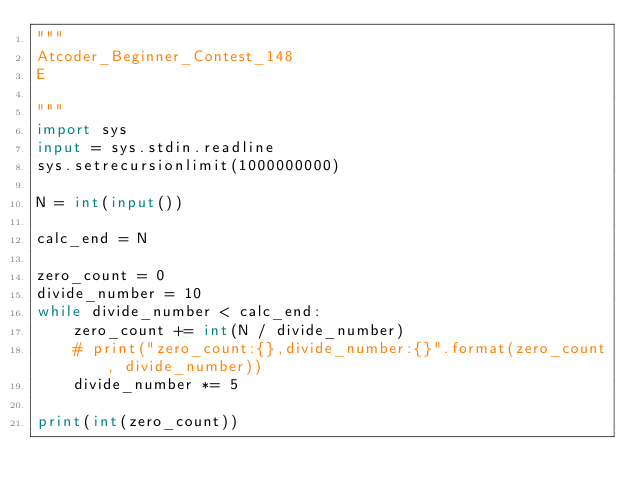Convert code to text. <code><loc_0><loc_0><loc_500><loc_500><_Python_>"""
Atcoder_Beginner_Contest_148
E

"""
import sys
input = sys.stdin.readline
sys.setrecursionlimit(1000000000)

N = int(input())

calc_end = N

zero_count = 0
divide_number = 10
while divide_number < calc_end:
    zero_count += int(N / divide_number)
    # print("zero_count:{},divide_number:{}".format(zero_count, divide_number))
    divide_number *= 5

print(int(zero_count))
</code> 